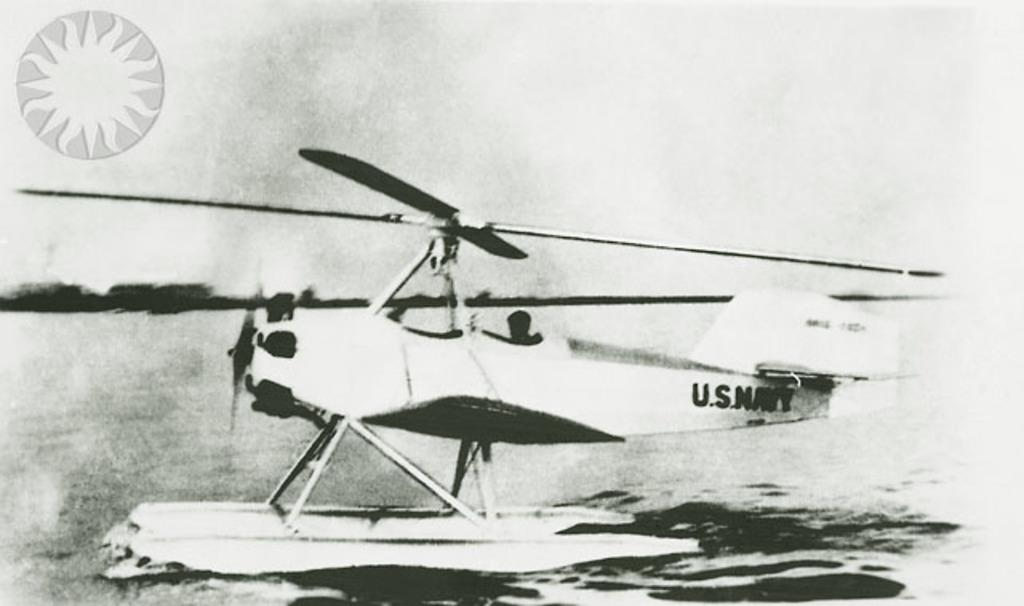Provide a one-sentence caption for the provided image. An airplane with the words U.S. Navy written on the tail. 